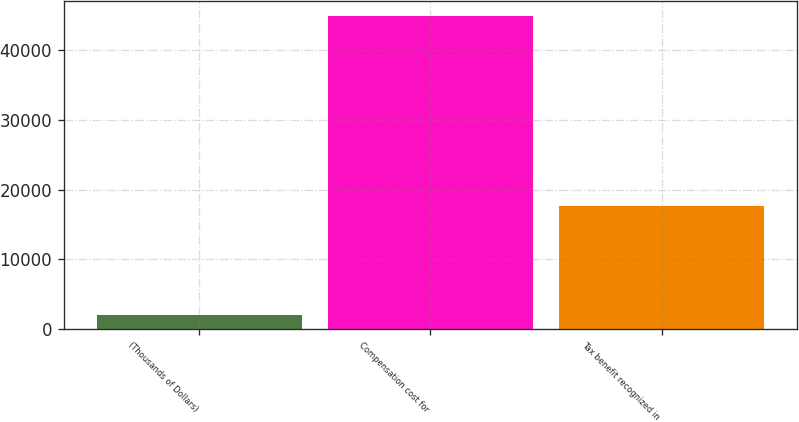Convert chart to OTSL. <chart><loc_0><loc_0><loc_500><loc_500><bar_chart><fcel>(Thousands of Dollars)<fcel>Compensation cost for<fcel>Tax benefit recognized in<nl><fcel>2015<fcel>44928<fcel>17570<nl></chart> 